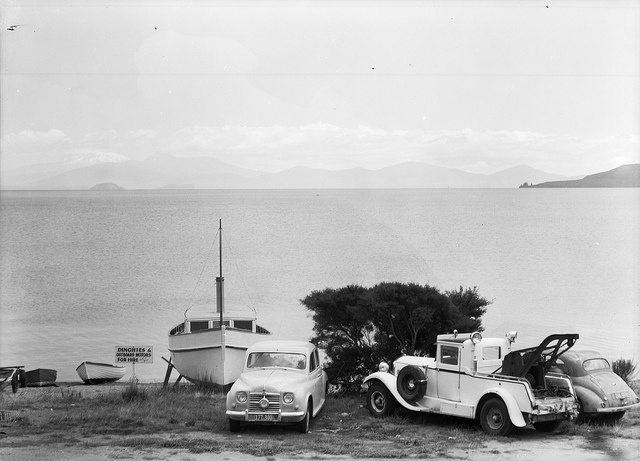Describe the objects in this image and their specific colors. I can see truck in lightgray, black, darkgray, and gray tones, boat in lightgray, darkgray, gray, and black tones, car in lightgray, darkgray, gray, and black tones, car in lightgray, darkgray, gray, and black tones, and boat in lightgray, darkgray, black, and gray tones in this image. 